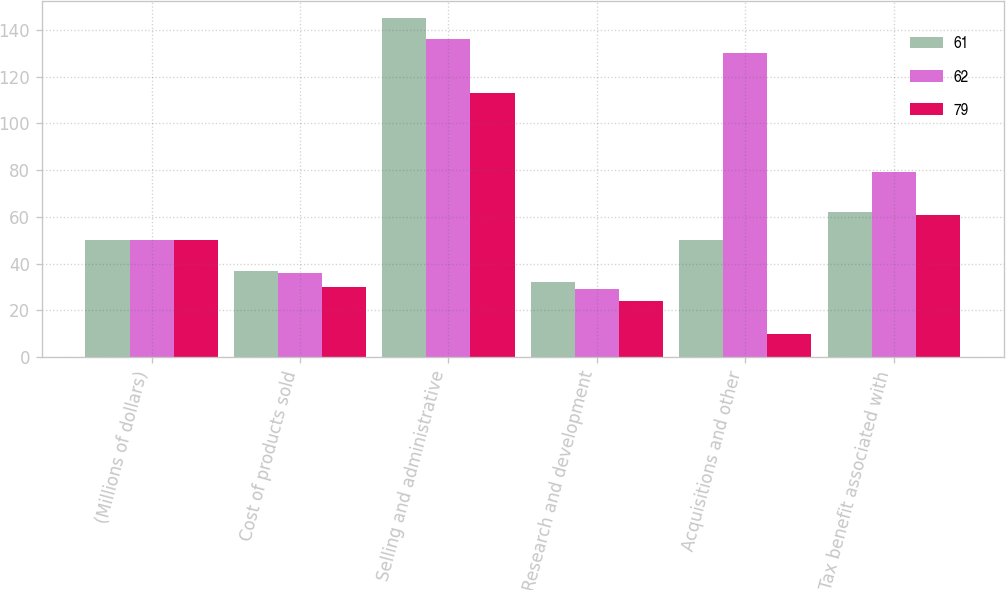Convert chart. <chart><loc_0><loc_0><loc_500><loc_500><stacked_bar_chart><ecel><fcel>(Millions of dollars)<fcel>Cost of products sold<fcel>Selling and administrative<fcel>Research and development<fcel>Acquisitions and other<fcel>Tax benefit associated with<nl><fcel>61<fcel>50<fcel>37<fcel>145<fcel>32<fcel>50<fcel>62<nl><fcel>62<fcel>50<fcel>36<fcel>136<fcel>29<fcel>130<fcel>79<nl><fcel>79<fcel>50<fcel>30<fcel>113<fcel>24<fcel>10<fcel>61<nl></chart> 